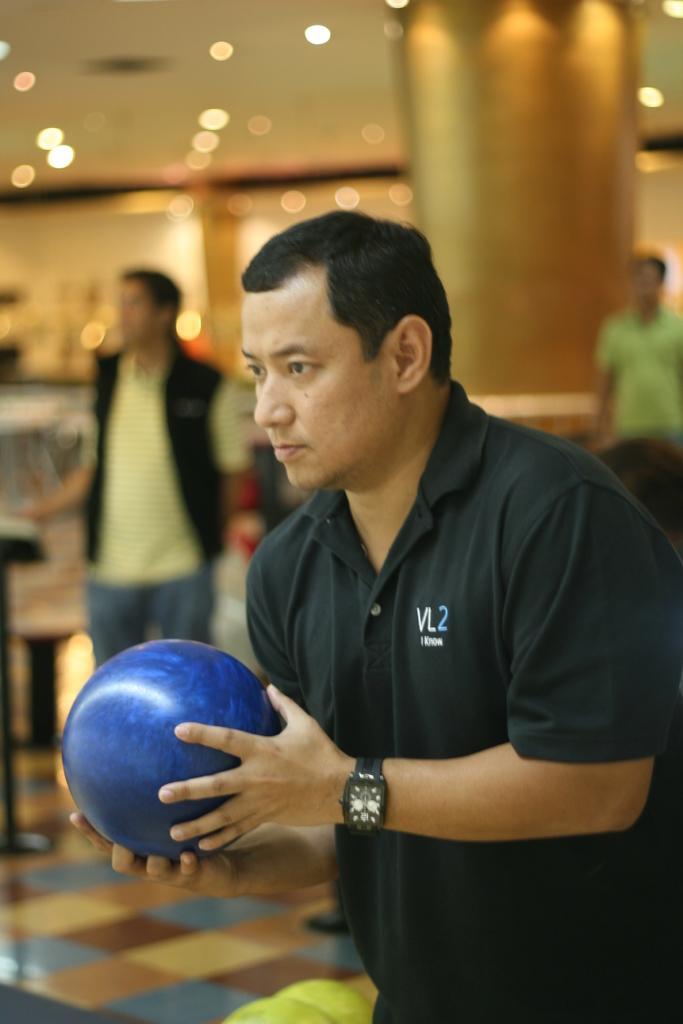How would you summarize this image in a sentence or two? In the image there is a man standing and holding a ball in the hand. And also there is a watch on his hand. Behind him there are two men. And there is a blur background with pillar and lights. 